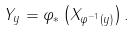<formula> <loc_0><loc_0><loc_500><loc_500>Y _ { y } = \varphi _ { * } \left ( X _ { \varphi ^ { - 1 } ( y ) } \right ) .</formula> 